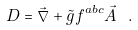<formula> <loc_0><loc_0><loc_500><loc_500>D = \vec { \nabla } + \tilde { g } f ^ { a b c } \vec { A } \ .</formula> 